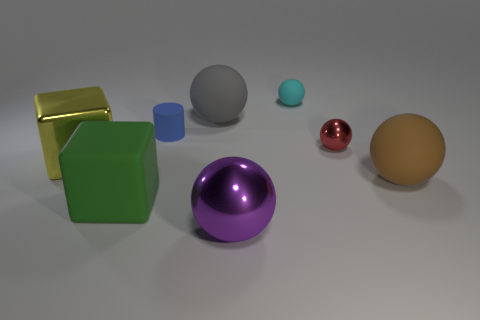What is the color of the large metallic object that is in front of the large cube that is in front of the big brown matte thing?
Ensure brevity in your answer.  Purple. What number of other objects are the same material as the brown sphere?
Offer a terse response. 4. There is a small thing in front of the tiny blue cylinder; what number of small cyan rubber spheres are to the right of it?
Your answer should be compact. 0. Is there any other thing that has the same shape as the yellow metallic thing?
Make the answer very short. Yes. There is a large rubber thing that is left of the big gray matte object; is its color the same as the rubber ball that is in front of the blue object?
Ensure brevity in your answer.  No. Are there fewer small blue cylinders than cubes?
Keep it short and to the point. Yes. The big object that is behind the small thing that is in front of the small blue cylinder is what shape?
Give a very brief answer. Sphere. Is there anything else that has the same size as the cyan rubber thing?
Provide a short and direct response. Yes. What is the shape of the big object to the right of the large metal thing that is right of the big thing that is behind the cylinder?
Your answer should be compact. Sphere. How many things are either metal spheres behind the big yellow metal cube or large matte balls behind the metallic cube?
Keep it short and to the point. 2. 